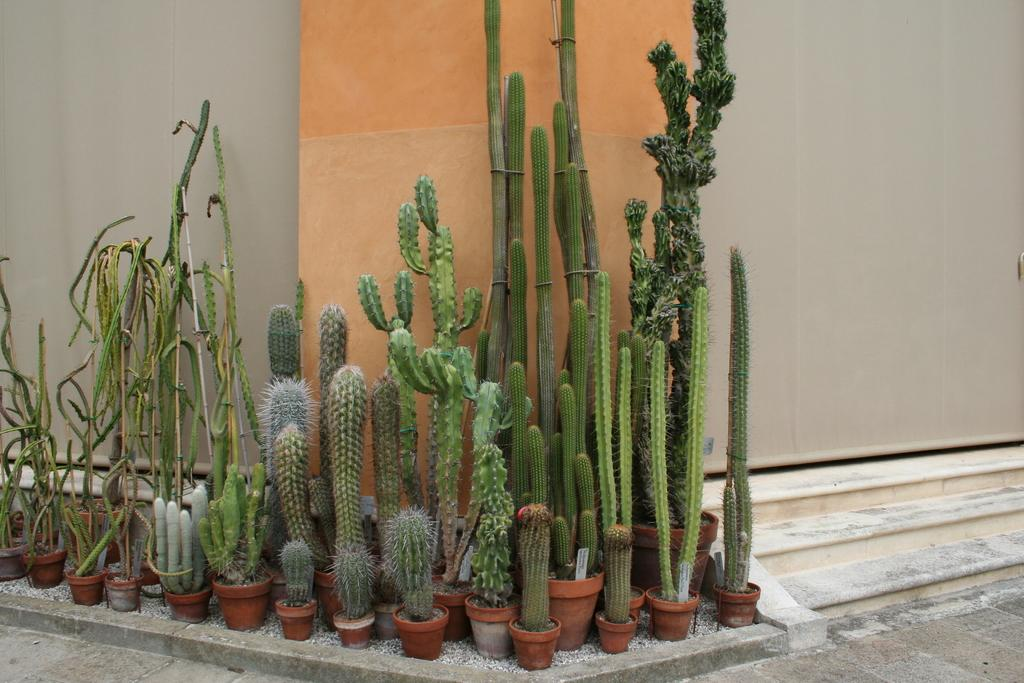What type of plants are in the image? The image contains desert plants. Where are the desert plants located? The desert plants are in a pot. What is visible in the background of the image? There is a wall and steps in the background of the image. How many times does the pail jump in the image? There is no pail present in the image, so it cannot jump or be counted. 